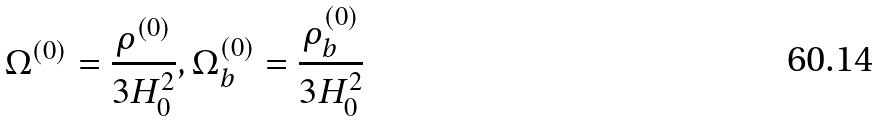Convert formula to latex. <formula><loc_0><loc_0><loc_500><loc_500>\Omega ^ { ( 0 ) } = \frac { \rho ^ { ( 0 ) } } { 3 H _ { 0 } ^ { 2 } } , \Omega _ { b } ^ { ( 0 ) } = \frac { \rho _ { b } ^ { ( 0 ) } } { 3 H _ { 0 } ^ { 2 } }</formula> 